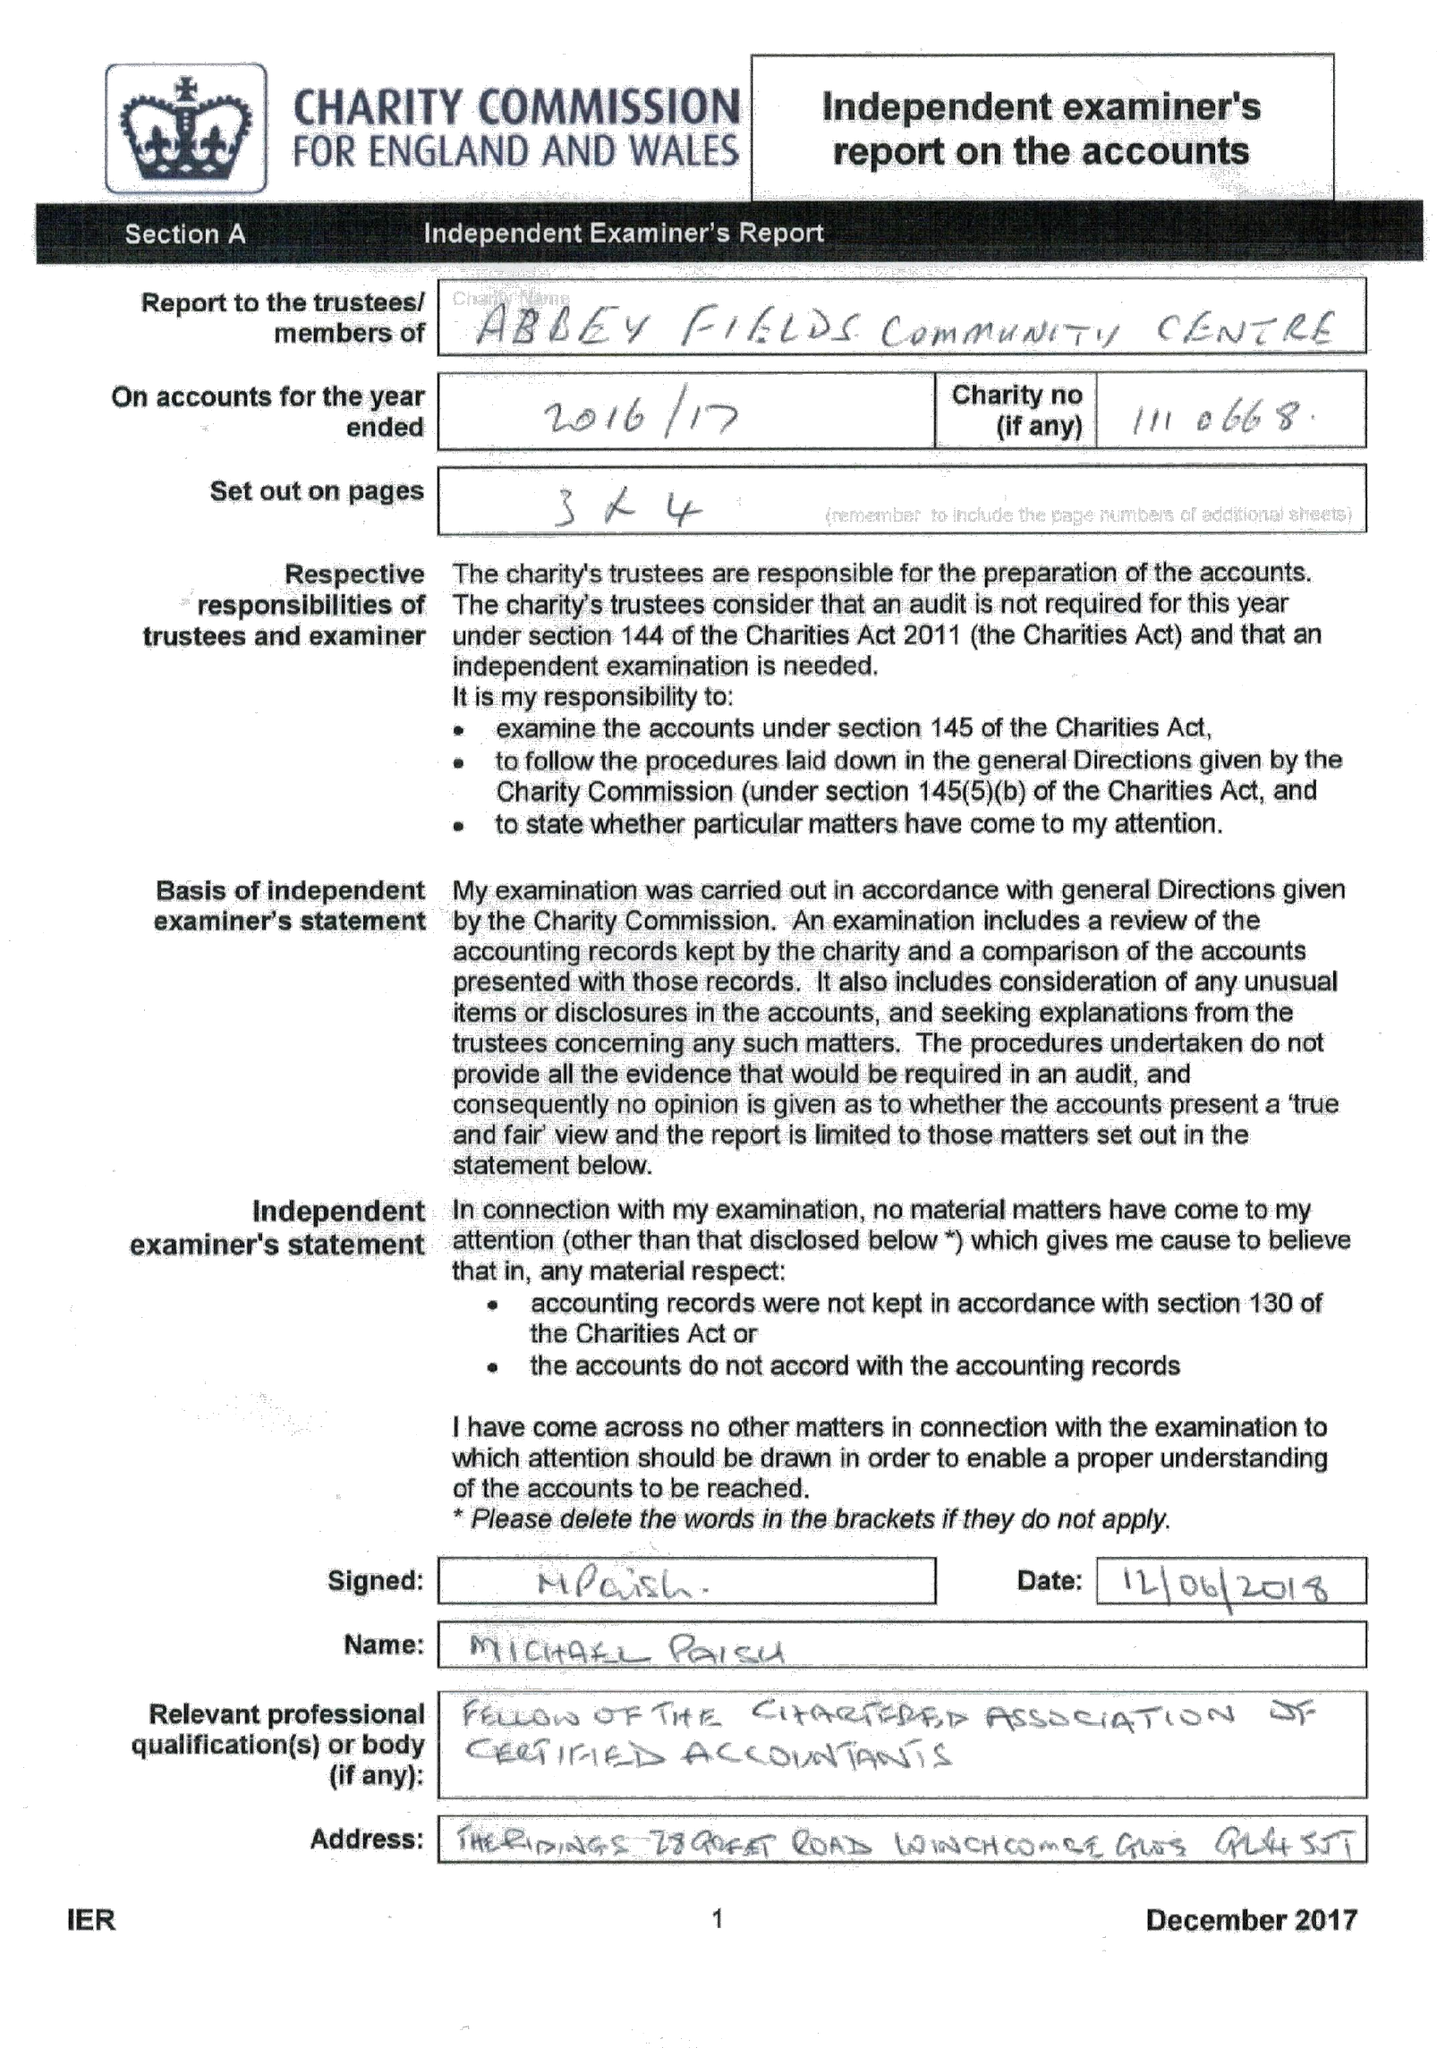What is the value for the address__post_town?
Answer the question using a single word or phrase. CHELTENHAM 